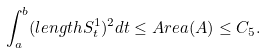Convert formula to latex. <formula><loc_0><loc_0><loc_500><loc_500>\int _ { a } ^ { b } ( l e n g t h S _ { t } ^ { 1 } ) ^ { 2 } d t \leq A r e a ( A ) \leq C _ { 5 } .</formula> 